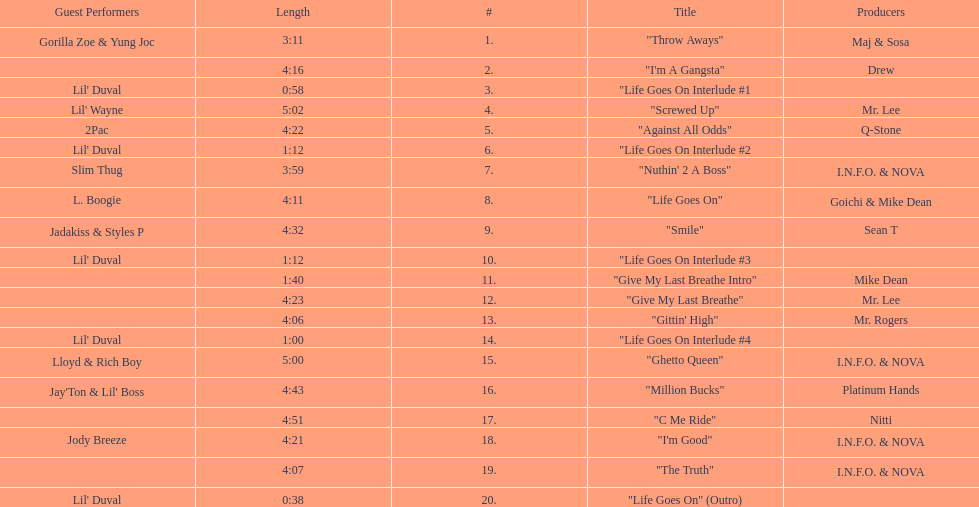How many tracks on trae's album "life goes on"? 20. 